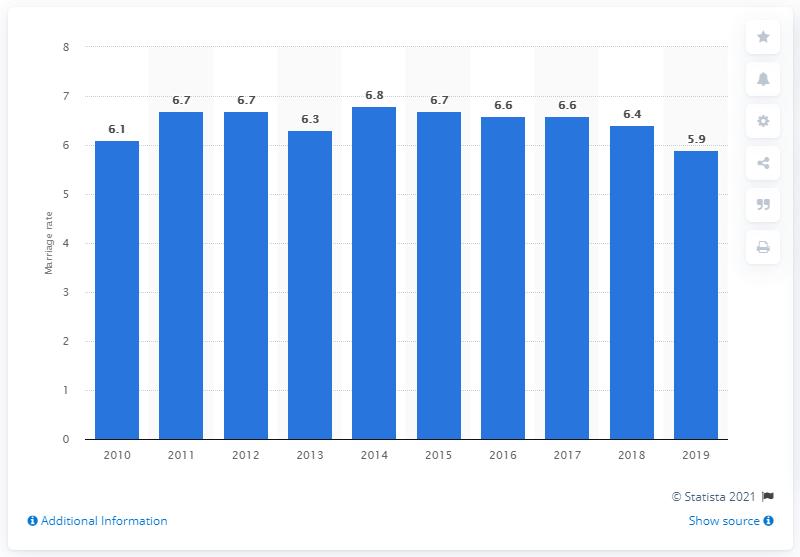Outline some significant characteristics in this image. The crude marriage rate in Singapore in 2019 was 5.9. 